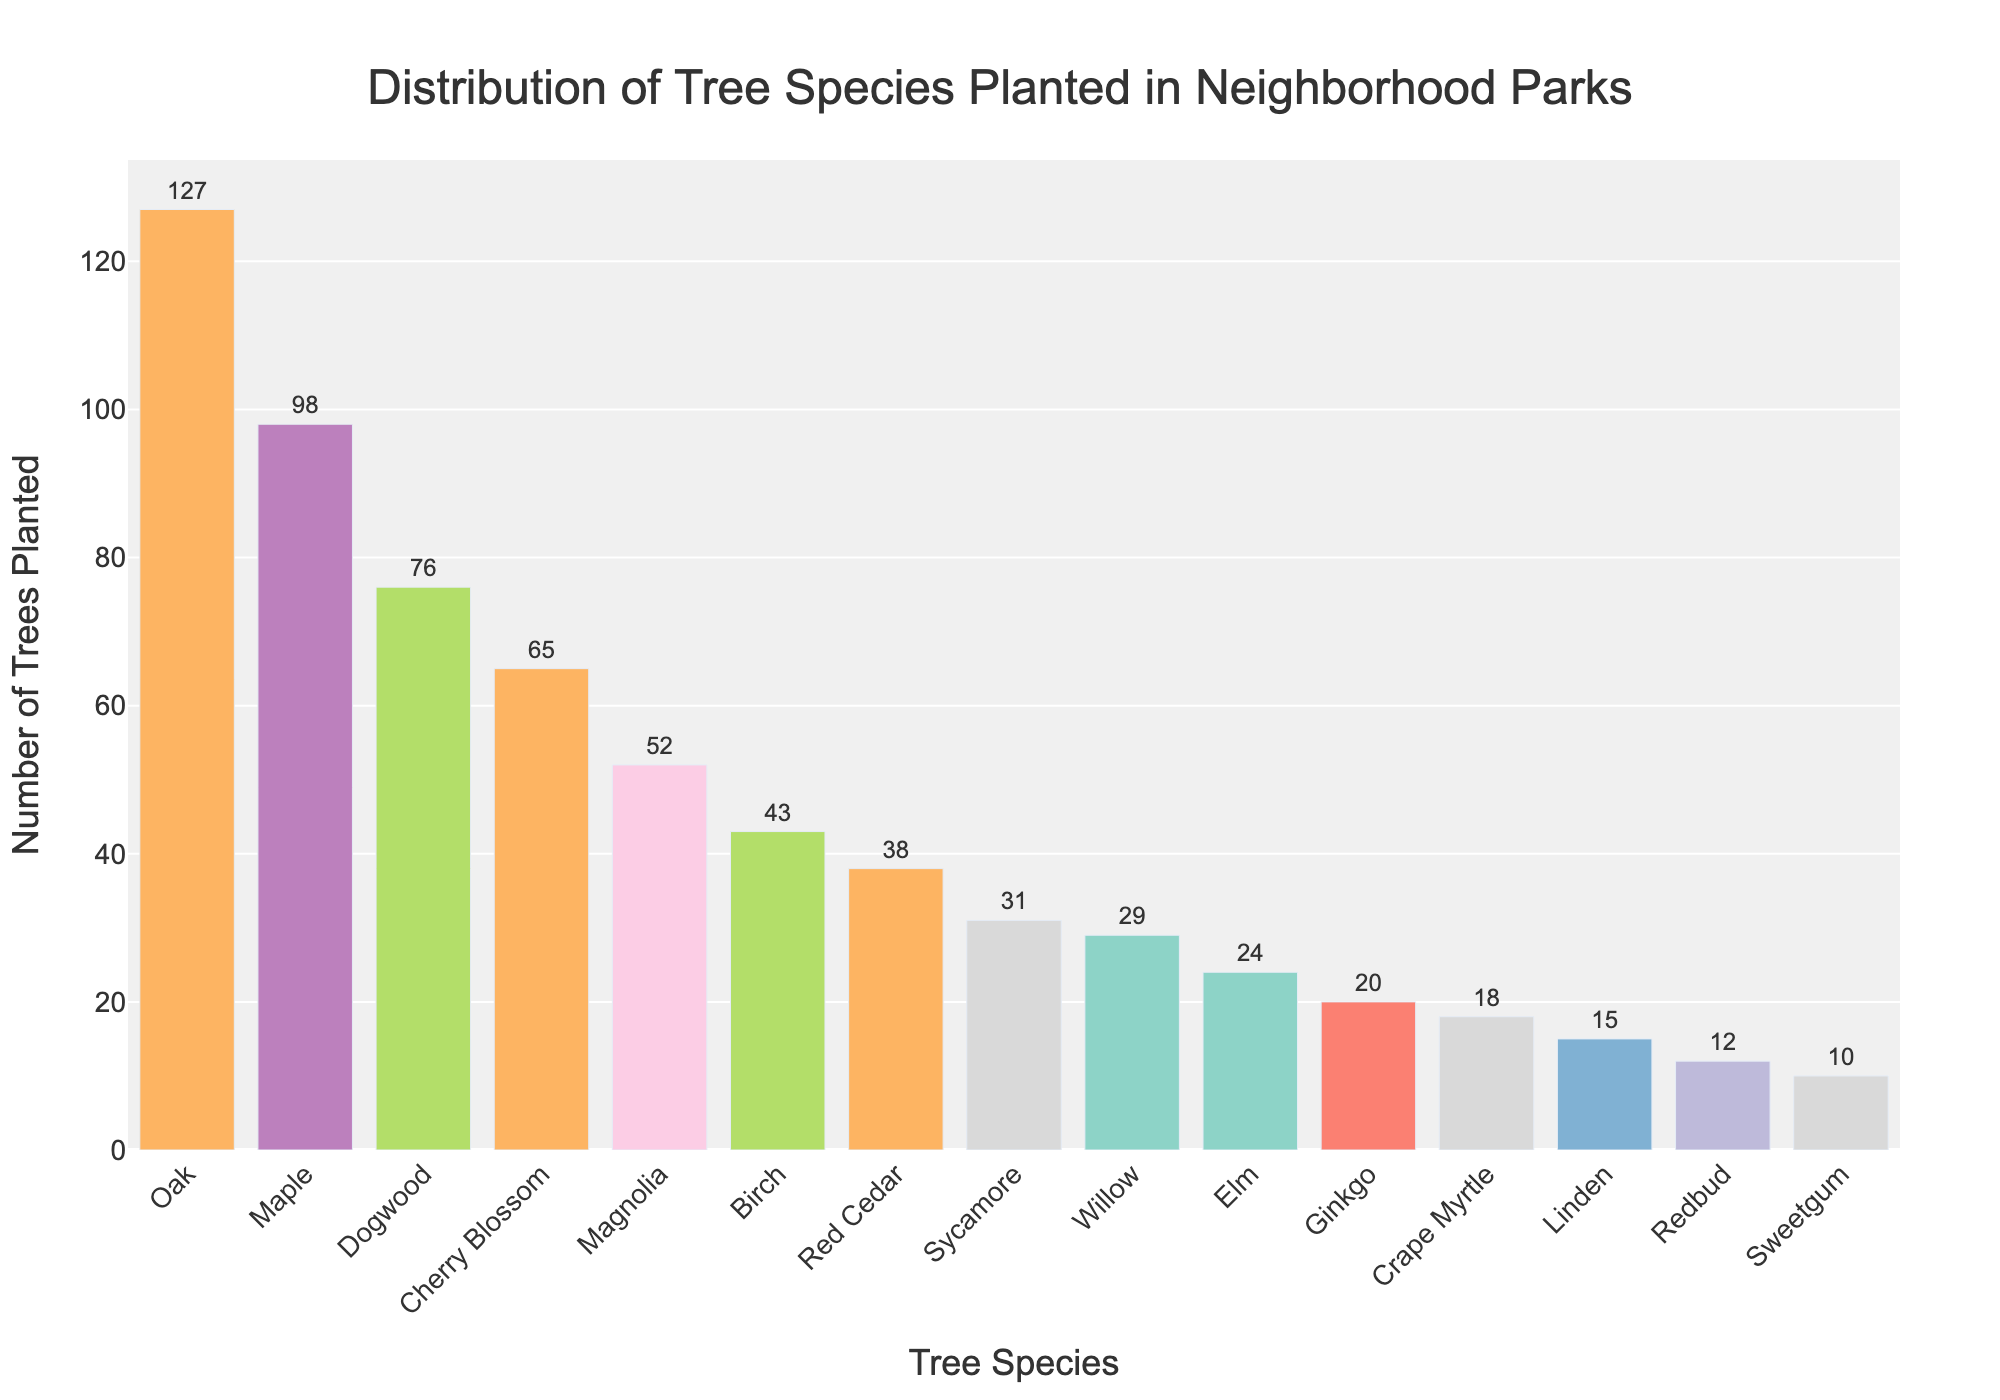Which tree species was planted the most? The tallest bar represents the tree species that was planted the most. Oak has the highest bar in the figure.
Answer: Oak How many Oak trees were planted over the past 5 years? The text on top of the bar for Oak indicates the number of Oak trees planted. The figure shows a value of 127 above the Oak bar.
Answer: 127 Which tree species was planted the least? The shortest bar represents the tree species that was planted the least. Sweetgum has the shortest bar in the figure.
Answer: Sweetgum How many more Oak trees were planted compared to Maple trees? To find the difference, subtract the number of Maple trees from the number of Oak trees. Oak has 127 and Maple has 98. Therefore, 127 - 98 = 29.
Answer: 29 What is the sum of Cherry Blossom and Magnolia trees planted? Add the numbers for Cherry Blossom and Magnolia trees. Cherry Blossom is 65 and Magnolia is 52. Thus, 65 + 52 = 117.
Answer: 117 Which tree species have numbers planted between 20 and 40? Look for bars whose numbers fall between 20 and 40. Red Cedar (38), Sycamore (31), and Willow (29) fall in this range.
Answer: Red Cedar, Sycamore, Willow What is the average number of trees planted for Ginkgo, Crape Myrtle, and Linden? Add the numbers for Ginkgo, Crape Myrtle, and Linden and divide by 3. Ginkgo has 20, Crape Myrtle has 18, Linden has 15. So, (20 + 18 + 15) / 3 = 17.67.
Answer: 17.67 Which tree species are highlighted by the rectangle shapes? The figure's highlighted rectangle shapes indicate the top 3 species. These are Oak, Maple, and Dogwood.
Answer: Oak, Maple, Dogwood Is the number of Birch trees planted more than the number of Red Cedar trees? Compare the height of the Birch bar to the Red Cedar bar. Birch has 43 and Red Cedar has 38. 43 is greater than 38.
Answer: Yes How does the number of Elm trees compare to Willow trees? Compare the height of the Elm bar to the Willow bar. Elm has 24 and Willow has 29. 24 is less than 29.
Answer: Less 